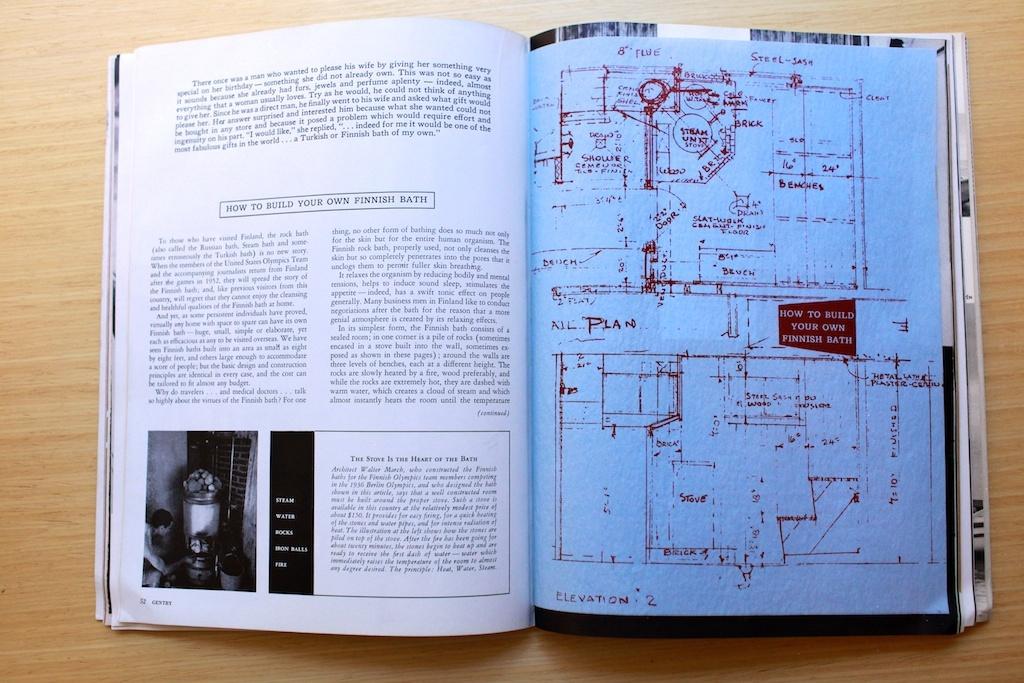What is this a blueprint of?
Your response must be concise. Finnish bath. What word is written at the very bottom left of the right page?
Your answer should be very brief. Elevation. 